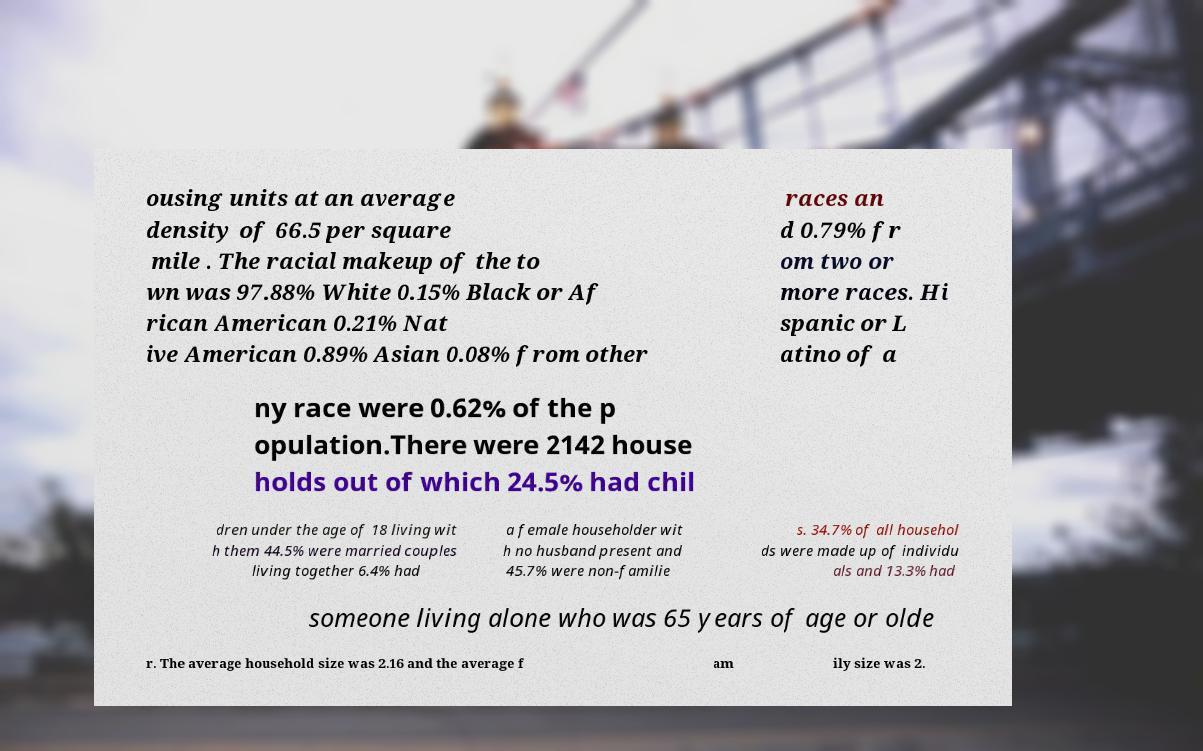What messages or text are displayed in this image? I need them in a readable, typed format. ousing units at an average density of 66.5 per square mile . The racial makeup of the to wn was 97.88% White 0.15% Black or Af rican American 0.21% Nat ive American 0.89% Asian 0.08% from other races an d 0.79% fr om two or more races. Hi spanic or L atino of a ny race were 0.62% of the p opulation.There were 2142 house holds out of which 24.5% had chil dren under the age of 18 living wit h them 44.5% were married couples living together 6.4% had a female householder wit h no husband present and 45.7% were non-familie s. 34.7% of all househol ds were made up of individu als and 13.3% had someone living alone who was 65 years of age or olde r. The average household size was 2.16 and the average f am ily size was 2. 